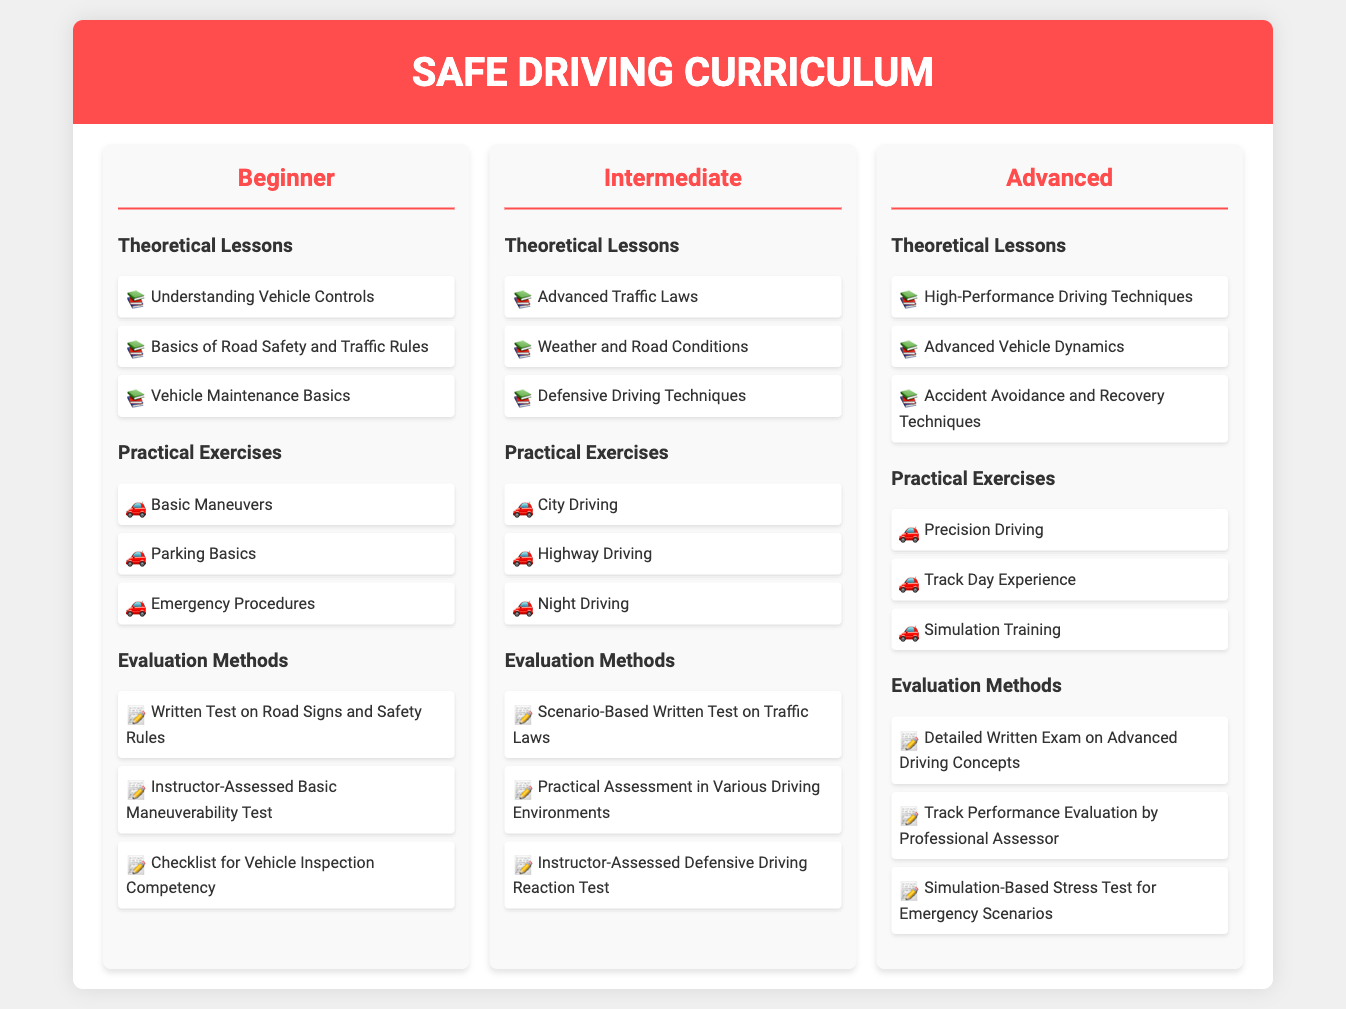What are the three levels of driving instruction? The document outlines three levels: Beginner, Intermediate, and Advanced.
Answer: Beginner, Intermediate, Advanced How many theoretical lessons are listed under the beginner level? There are three theoretical lessons provided for the beginner level.
Answer: 3 What practical exercise is included in the intermediate level? The intermediate level includes practical exercises such as City Driving, Highway Driving, and Night Driving. One example is City Driving.
Answer: City Driving What is the primary focus of the advanced theoretical lessons? The advanced theoretical lessons focus on High-Performance Driving Techniques, Advanced Vehicle Dynamics, and Accident Avoidance and Recovery Techniques.
Answer: High-Performance Driving Techniques What type of evaluation method is used for assessing defensive driving at the intermediate level? The evaluation method used is the Instructor-Assessed Defensive Driving Reaction Test.
Answer: Instructor-Assessed Defensive Driving Reaction Test How many practical exercises are under the advanced level? The advanced level includes three practical exercises: Precision Driving, Track Day Experience, and Simulation Training.
Answer: 3 What is the icon used for theoretical lessons? The icon that represents theoretical lessons in the document is a book emoji.
Answer: 📚 What is the evaluation method for the beginner level that assesses the ability to recognize road signs? The evaluation method for assessing road signs is a Written Test on Road Signs and Safety Rules.
Answer: Written Test on Road Signs and Safety Rules 